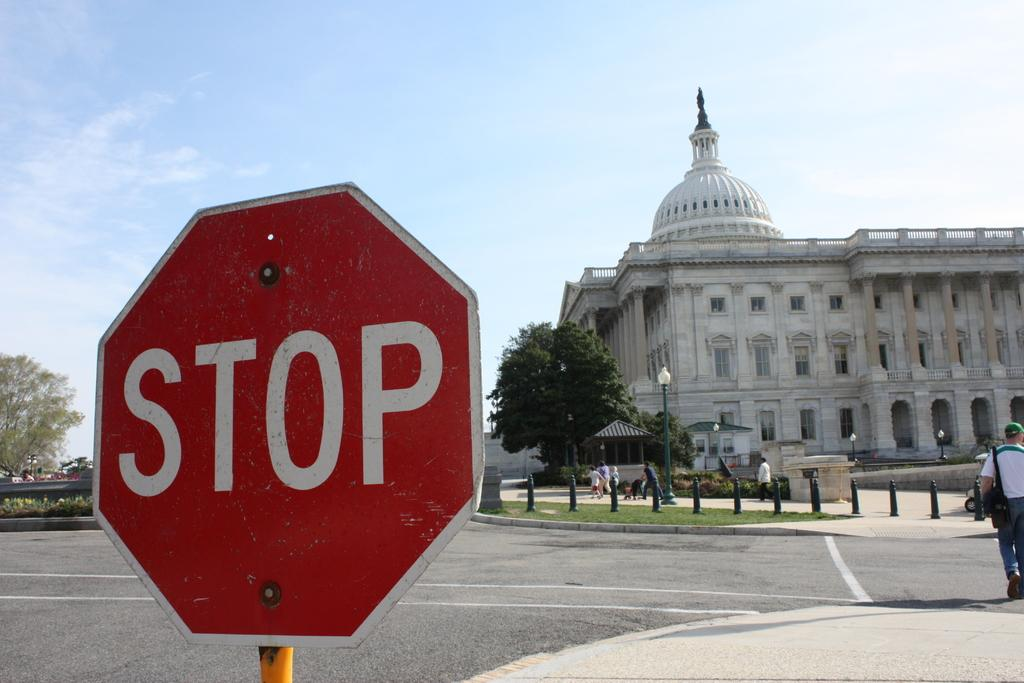<image>
Create a compact narrative representing the image presented. A red and white stop sign is sitting next to an intersection and a large building behind it. 